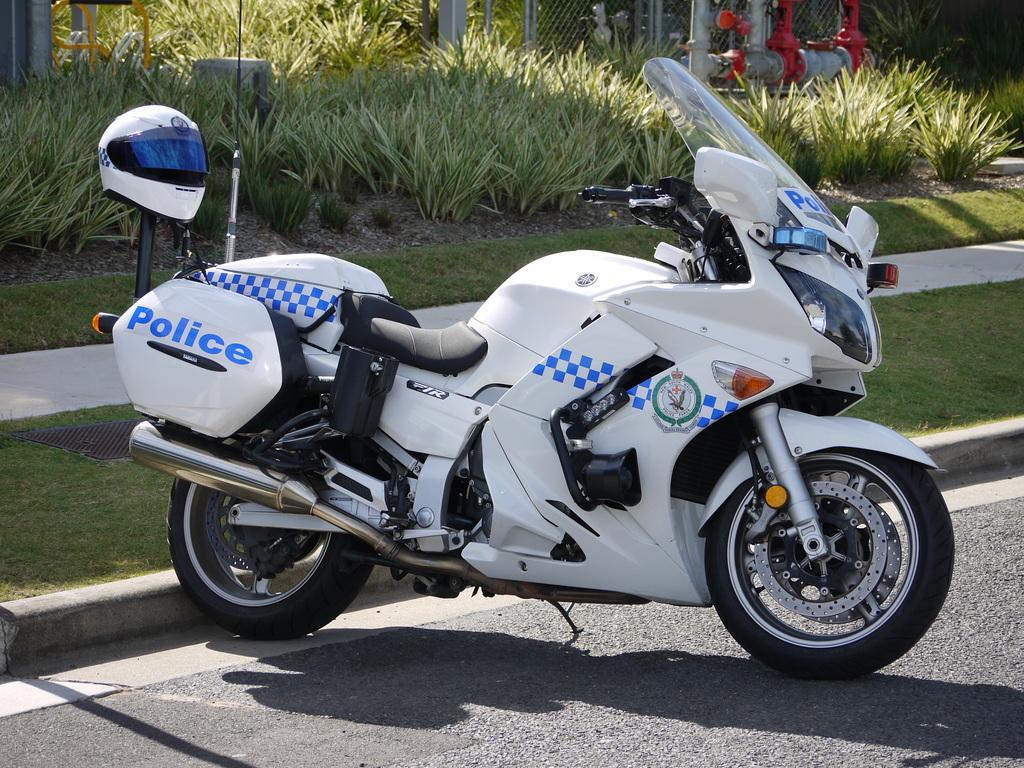How would you summarize this image in a sentence or two? In this image we can see a vehicle. There is a helmet in the image. There is a grassy land in the image. There are many trees in the image. We can see the road safety marking on the road. There are few pipes at the right side of the image. 